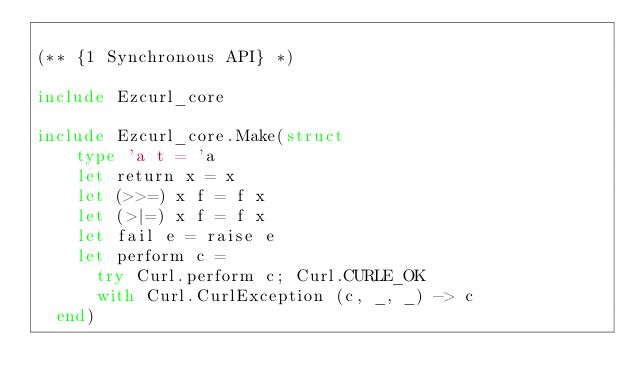<code> <loc_0><loc_0><loc_500><loc_500><_OCaml_>
(** {1 Synchronous API} *)

include Ezcurl_core

include Ezcurl_core.Make(struct
    type 'a t = 'a
    let return x = x
    let (>>=) x f = f x
    let (>|=) x f = f x
    let fail e = raise e
    let perform c =
      try Curl.perform c; Curl.CURLE_OK
      with Curl.CurlException (c, _, _) -> c
  end)

</code> 